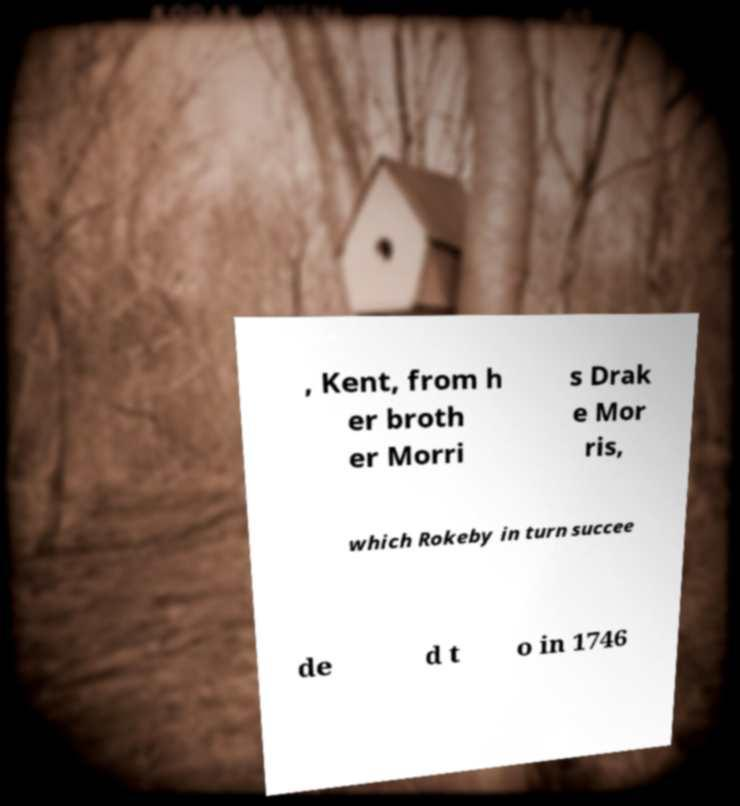Please read and relay the text visible in this image. What does it say? , Kent, from h er broth er Morri s Drak e Mor ris, which Rokeby in turn succee de d t o in 1746 